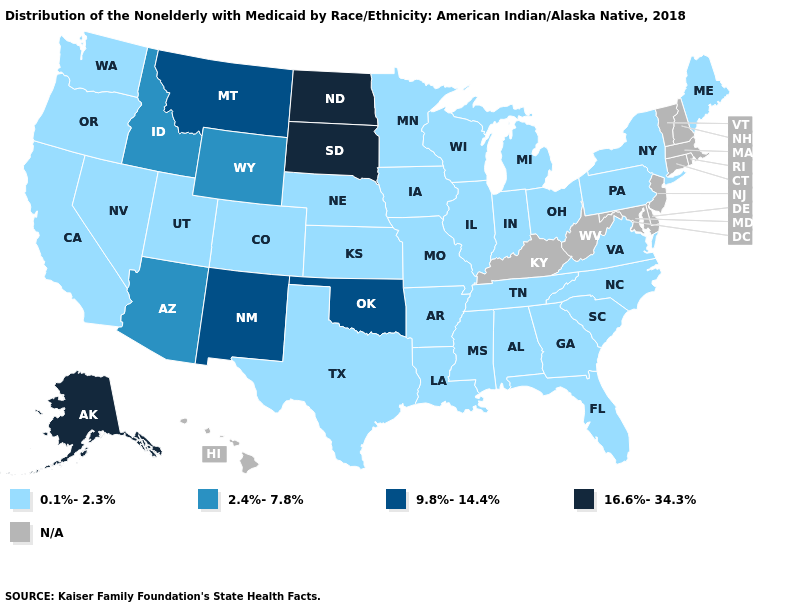What is the value of Maryland?
Short answer required. N/A. What is the value of New Jersey?
Quick response, please. N/A. Name the states that have a value in the range 2.4%-7.8%?
Write a very short answer. Arizona, Idaho, Wyoming. What is the lowest value in the Northeast?
Give a very brief answer. 0.1%-2.3%. What is the lowest value in the USA?
Be succinct. 0.1%-2.3%. What is the value of Connecticut?
Quick response, please. N/A. What is the value of Nebraska?
Quick response, please. 0.1%-2.3%. What is the value of Minnesota?
Write a very short answer. 0.1%-2.3%. Which states have the highest value in the USA?
Keep it brief. Alaska, North Dakota, South Dakota. What is the value of Kentucky?
Quick response, please. N/A. Does Minnesota have the highest value in the MidWest?
Answer briefly. No. Among the states that border North Dakota , which have the highest value?
Keep it brief. South Dakota. Among the states that border Wisconsin , which have the highest value?
Quick response, please. Illinois, Iowa, Michigan, Minnesota. What is the value of Washington?
Keep it brief. 0.1%-2.3%. 